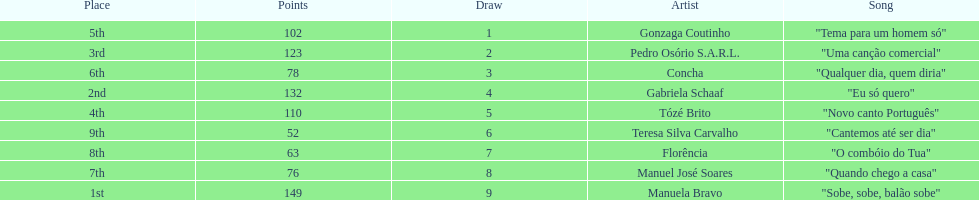What is the total amount of points for florencia? 63. 